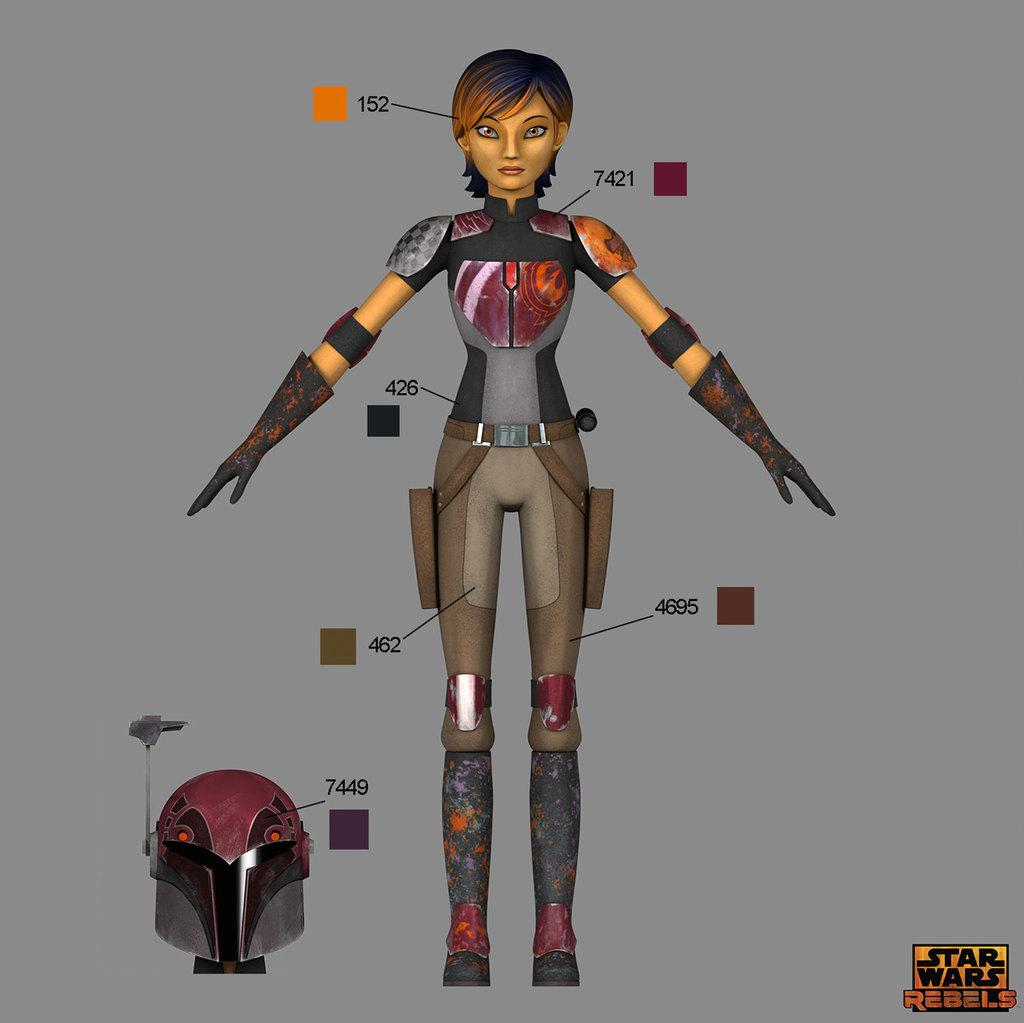What type of character is present in the image? The image contains an animated person. What protective gear is visible in the image? There is a helmet visible in the image. What color is the background of the image? The background of the image is grey. What type of stamp can be seen on the animated person's forehead in the image? There is no stamp visible on the animated person's forehead in the image. 